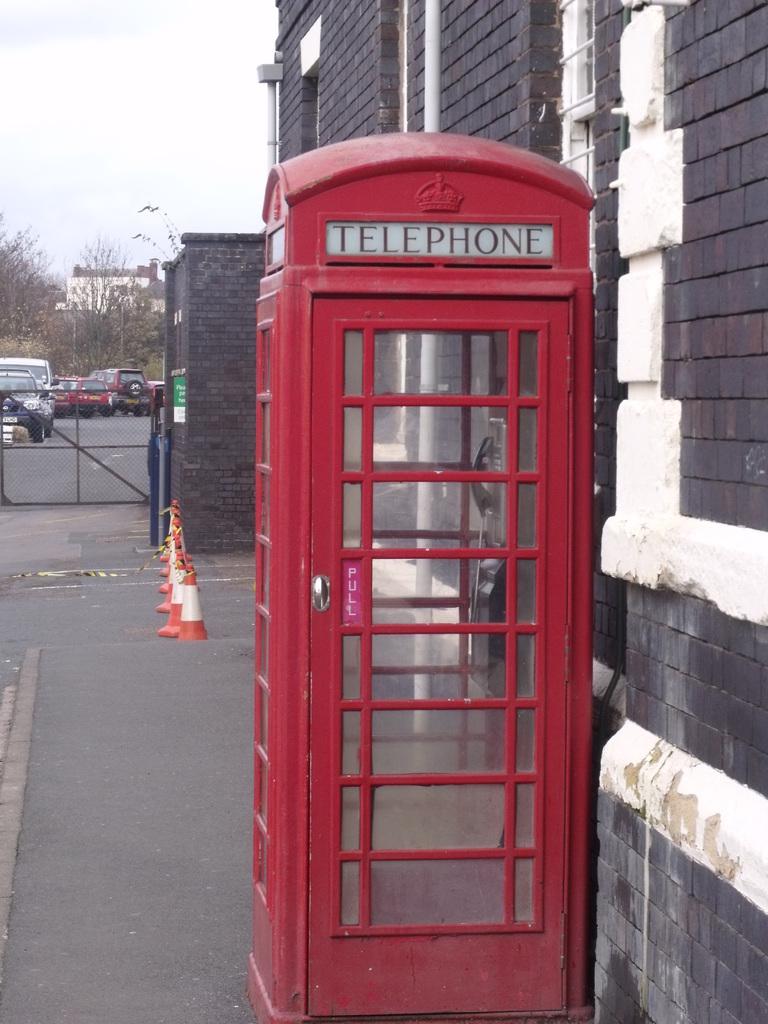What is this booth for?
Your answer should be compact. Telephone. This is kain?
Give a very brief answer. No. 